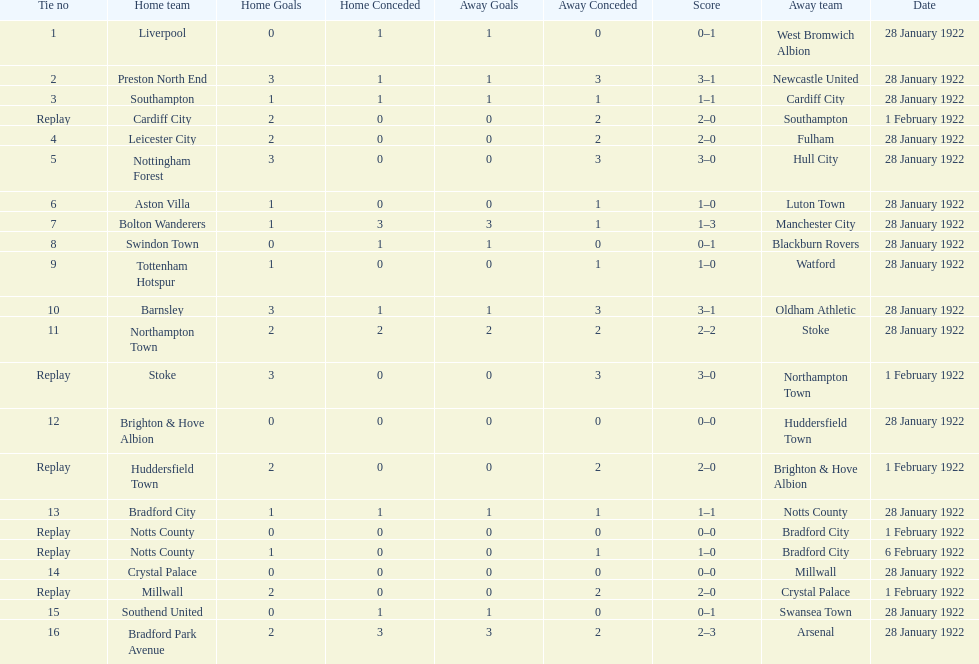What date did they play before feb 1? 28 January 1922. 